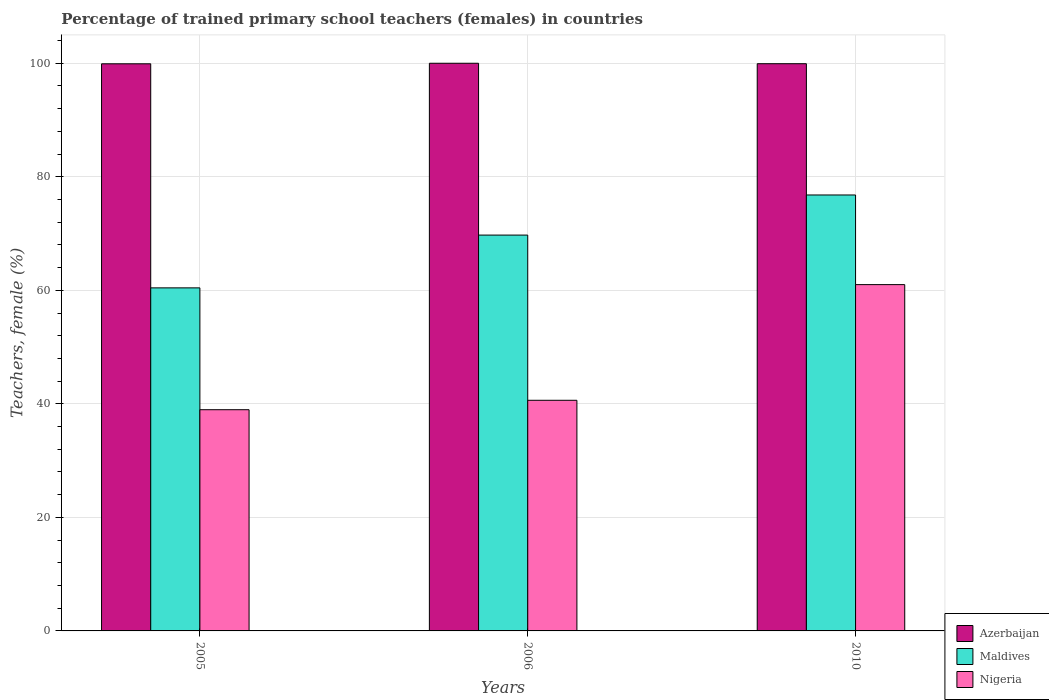How many different coloured bars are there?
Offer a very short reply. 3. How many groups of bars are there?
Make the answer very short. 3. Are the number of bars on each tick of the X-axis equal?
Provide a short and direct response. Yes. How many bars are there on the 1st tick from the left?
Your answer should be compact. 3. How many bars are there on the 2nd tick from the right?
Your response must be concise. 3. In how many cases, is the number of bars for a given year not equal to the number of legend labels?
Offer a very short reply. 0. What is the percentage of trained primary school teachers (females) in Azerbaijan in 2005?
Your answer should be compact. 99.9. Across all years, what is the maximum percentage of trained primary school teachers (females) in Nigeria?
Ensure brevity in your answer.  61.01. Across all years, what is the minimum percentage of trained primary school teachers (females) in Maldives?
Make the answer very short. 60.43. In which year was the percentage of trained primary school teachers (females) in Maldives maximum?
Provide a short and direct response. 2010. In which year was the percentage of trained primary school teachers (females) in Azerbaijan minimum?
Your answer should be very brief. 2005. What is the total percentage of trained primary school teachers (females) in Maldives in the graph?
Provide a succinct answer. 206.96. What is the difference between the percentage of trained primary school teachers (females) in Maldives in 2005 and that in 2006?
Offer a very short reply. -9.3. What is the difference between the percentage of trained primary school teachers (females) in Maldives in 2010 and the percentage of trained primary school teachers (females) in Nigeria in 2005?
Provide a succinct answer. 37.83. What is the average percentage of trained primary school teachers (females) in Azerbaijan per year?
Keep it short and to the point. 99.94. In the year 2005, what is the difference between the percentage of trained primary school teachers (females) in Azerbaijan and percentage of trained primary school teachers (females) in Maldives?
Give a very brief answer. 39.47. In how many years, is the percentage of trained primary school teachers (females) in Maldives greater than 44 %?
Your response must be concise. 3. What is the ratio of the percentage of trained primary school teachers (females) in Nigeria in 2005 to that in 2010?
Your answer should be very brief. 0.64. Is the difference between the percentage of trained primary school teachers (females) in Azerbaijan in 2005 and 2006 greater than the difference between the percentage of trained primary school teachers (females) in Maldives in 2005 and 2006?
Ensure brevity in your answer.  Yes. What is the difference between the highest and the second highest percentage of trained primary school teachers (females) in Maldives?
Ensure brevity in your answer.  7.06. What is the difference between the highest and the lowest percentage of trained primary school teachers (females) in Nigeria?
Your answer should be compact. 22.04. In how many years, is the percentage of trained primary school teachers (females) in Azerbaijan greater than the average percentage of trained primary school teachers (females) in Azerbaijan taken over all years?
Offer a terse response. 1. What does the 1st bar from the left in 2010 represents?
Ensure brevity in your answer.  Azerbaijan. What does the 3rd bar from the right in 2010 represents?
Provide a succinct answer. Azerbaijan. How many bars are there?
Ensure brevity in your answer.  9. Are all the bars in the graph horizontal?
Keep it short and to the point. No. How many years are there in the graph?
Your answer should be very brief. 3. What is the difference between two consecutive major ticks on the Y-axis?
Provide a succinct answer. 20. Does the graph contain any zero values?
Your answer should be compact. No. Does the graph contain grids?
Keep it short and to the point. Yes. What is the title of the graph?
Offer a terse response. Percentage of trained primary school teachers (females) in countries. Does "Jamaica" appear as one of the legend labels in the graph?
Your answer should be compact. No. What is the label or title of the X-axis?
Your answer should be very brief. Years. What is the label or title of the Y-axis?
Your answer should be compact. Teachers, female (%). What is the Teachers, female (%) in Azerbaijan in 2005?
Your response must be concise. 99.9. What is the Teachers, female (%) of Maldives in 2005?
Keep it short and to the point. 60.43. What is the Teachers, female (%) of Nigeria in 2005?
Your response must be concise. 38.97. What is the Teachers, female (%) of Azerbaijan in 2006?
Your answer should be very brief. 100. What is the Teachers, female (%) of Maldives in 2006?
Provide a succinct answer. 69.73. What is the Teachers, female (%) of Nigeria in 2006?
Keep it short and to the point. 40.63. What is the Teachers, female (%) in Azerbaijan in 2010?
Make the answer very short. 99.92. What is the Teachers, female (%) of Maldives in 2010?
Offer a terse response. 76.8. What is the Teachers, female (%) in Nigeria in 2010?
Make the answer very short. 61.01. Across all years, what is the maximum Teachers, female (%) of Azerbaijan?
Offer a terse response. 100. Across all years, what is the maximum Teachers, female (%) of Maldives?
Give a very brief answer. 76.8. Across all years, what is the maximum Teachers, female (%) of Nigeria?
Give a very brief answer. 61.01. Across all years, what is the minimum Teachers, female (%) in Azerbaijan?
Provide a short and direct response. 99.9. Across all years, what is the minimum Teachers, female (%) in Maldives?
Offer a terse response. 60.43. Across all years, what is the minimum Teachers, female (%) in Nigeria?
Make the answer very short. 38.97. What is the total Teachers, female (%) in Azerbaijan in the graph?
Give a very brief answer. 299.82. What is the total Teachers, female (%) in Maldives in the graph?
Ensure brevity in your answer.  206.96. What is the total Teachers, female (%) in Nigeria in the graph?
Your response must be concise. 140.6. What is the difference between the Teachers, female (%) of Azerbaijan in 2005 and that in 2006?
Provide a succinct answer. -0.1. What is the difference between the Teachers, female (%) of Maldives in 2005 and that in 2006?
Give a very brief answer. -9.3. What is the difference between the Teachers, female (%) of Nigeria in 2005 and that in 2006?
Your answer should be very brief. -1.66. What is the difference between the Teachers, female (%) of Azerbaijan in 2005 and that in 2010?
Offer a terse response. -0.02. What is the difference between the Teachers, female (%) in Maldives in 2005 and that in 2010?
Ensure brevity in your answer.  -16.36. What is the difference between the Teachers, female (%) of Nigeria in 2005 and that in 2010?
Your answer should be compact. -22.04. What is the difference between the Teachers, female (%) of Azerbaijan in 2006 and that in 2010?
Keep it short and to the point. 0.08. What is the difference between the Teachers, female (%) in Maldives in 2006 and that in 2010?
Provide a succinct answer. -7.06. What is the difference between the Teachers, female (%) of Nigeria in 2006 and that in 2010?
Offer a terse response. -20.38. What is the difference between the Teachers, female (%) in Azerbaijan in 2005 and the Teachers, female (%) in Maldives in 2006?
Your answer should be compact. 30.17. What is the difference between the Teachers, female (%) of Azerbaijan in 2005 and the Teachers, female (%) of Nigeria in 2006?
Ensure brevity in your answer.  59.27. What is the difference between the Teachers, female (%) in Maldives in 2005 and the Teachers, female (%) in Nigeria in 2006?
Your response must be concise. 19.8. What is the difference between the Teachers, female (%) of Azerbaijan in 2005 and the Teachers, female (%) of Maldives in 2010?
Your response must be concise. 23.11. What is the difference between the Teachers, female (%) of Azerbaijan in 2005 and the Teachers, female (%) of Nigeria in 2010?
Offer a very short reply. 38.9. What is the difference between the Teachers, female (%) in Maldives in 2005 and the Teachers, female (%) in Nigeria in 2010?
Provide a short and direct response. -0.57. What is the difference between the Teachers, female (%) in Azerbaijan in 2006 and the Teachers, female (%) in Maldives in 2010?
Your response must be concise. 23.2. What is the difference between the Teachers, female (%) of Azerbaijan in 2006 and the Teachers, female (%) of Nigeria in 2010?
Provide a succinct answer. 38.99. What is the difference between the Teachers, female (%) in Maldives in 2006 and the Teachers, female (%) in Nigeria in 2010?
Ensure brevity in your answer.  8.72. What is the average Teachers, female (%) in Azerbaijan per year?
Keep it short and to the point. 99.94. What is the average Teachers, female (%) in Maldives per year?
Provide a short and direct response. 68.99. What is the average Teachers, female (%) in Nigeria per year?
Your response must be concise. 46.87. In the year 2005, what is the difference between the Teachers, female (%) in Azerbaijan and Teachers, female (%) in Maldives?
Make the answer very short. 39.47. In the year 2005, what is the difference between the Teachers, female (%) in Azerbaijan and Teachers, female (%) in Nigeria?
Your answer should be compact. 60.93. In the year 2005, what is the difference between the Teachers, female (%) in Maldives and Teachers, female (%) in Nigeria?
Your answer should be compact. 21.46. In the year 2006, what is the difference between the Teachers, female (%) in Azerbaijan and Teachers, female (%) in Maldives?
Your answer should be very brief. 30.27. In the year 2006, what is the difference between the Teachers, female (%) in Azerbaijan and Teachers, female (%) in Nigeria?
Your answer should be compact. 59.37. In the year 2006, what is the difference between the Teachers, female (%) in Maldives and Teachers, female (%) in Nigeria?
Your response must be concise. 29.1. In the year 2010, what is the difference between the Teachers, female (%) of Azerbaijan and Teachers, female (%) of Maldives?
Make the answer very short. 23.13. In the year 2010, what is the difference between the Teachers, female (%) in Azerbaijan and Teachers, female (%) in Nigeria?
Ensure brevity in your answer.  38.92. In the year 2010, what is the difference between the Teachers, female (%) of Maldives and Teachers, female (%) of Nigeria?
Give a very brief answer. 15.79. What is the ratio of the Teachers, female (%) of Maldives in 2005 to that in 2006?
Ensure brevity in your answer.  0.87. What is the ratio of the Teachers, female (%) in Nigeria in 2005 to that in 2006?
Make the answer very short. 0.96. What is the ratio of the Teachers, female (%) in Azerbaijan in 2005 to that in 2010?
Ensure brevity in your answer.  1. What is the ratio of the Teachers, female (%) of Maldives in 2005 to that in 2010?
Give a very brief answer. 0.79. What is the ratio of the Teachers, female (%) in Nigeria in 2005 to that in 2010?
Ensure brevity in your answer.  0.64. What is the ratio of the Teachers, female (%) in Azerbaijan in 2006 to that in 2010?
Your response must be concise. 1. What is the ratio of the Teachers, female (%) of Maldives in 2006 to that in 2010?
Provide a short and direct response. 0.91. What is the ratio of the Teachers, female (%) in Nigeria in 2006 to that in 2010?
Provide a succinct answer. 0.67. What is the difference between the highest and the second highest Teachers, female (%) in Azerbaijan?
Offer a very short reply. 0.08. What is the difference between the highest and the second highest Teachers, female (%) in Maldives?
Keep it short and to the point. 7.06. What is the difference between the highest and the second highest Teachers, female (%) of Nigeria?
Provide a short and direct response. 20.38. What is the difference between the highest and the lowest Teachers, female (%) of Azerbaijan?
Provide a short and direct response. 0.1. What is the difference between the highest and the lowest Teachers, female (%) of Maldives?
Ensure brevity in your answer.  16.36. What is the difference between the highest and the lowest Teachers, female (%) of Nigeria?
Give a very brief answer. 22.04. 